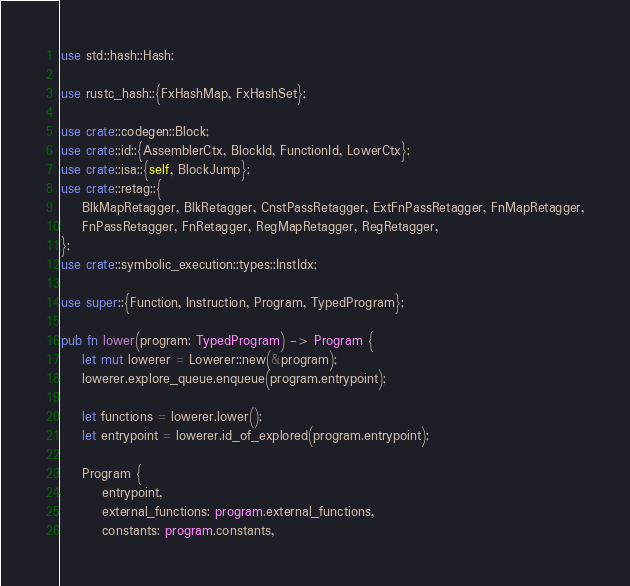Convert code to text. <code><loc_0><loc_0><loc_500><loc_500><_Rust_>use std::hash::Hash;

use rustc_hash::{FxHashMap, FxHashSet};

use crate::codegen::Block;
use crate::id::{AssemblerCtx, BlockId, FunctionId, LowerCtx};
use crate::isa::{self, BlockJump};
use crate::retag::{
    BlkMapRetagger, BlkRetagger, CnstPassRetagger, ExtFnPassRetagger, FnMapRetagger,
    FnPassRetagger, FnRetagger, RegMapRetagger, RegRetagger,
};
use crate::symbolic_execution::types::InstIdx;

use super::{Function, Instruction, Program, TypedProgram};

pub fn lower(program: TypedProgram) -> Program {
    let mut lowerer = Lowerer::new(&program);
    lowerer.explore_queue.enqueue(program.entrypoint);

    let functions = lowerer.lower();
    let entrypoint = lowerer.id_of_explored(program.entrypoint);

    Program {
        entrypoint,
        external_functions: program.external_functions,
        constants: program.constants,</code> 